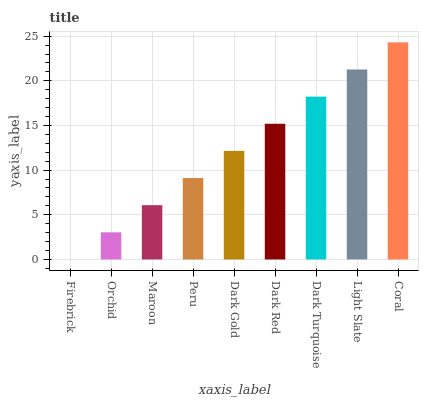Is Firebrick the minimum?
Answer yes or no. Yes. Is Coral the maximum?
Answer yes or no. Yes. Is Orchid the minimum?
Answer yes or no. No. Is Orchid the maximum?
Answer yes or no. No. Is Orchid greater than Firebrick?
Answer yes or no. Yes. Is Firebrick less than Orchid?
Answer yes or no. Yes. Is Firebrick greater than Orchid?
Answer yes or no. No. Is Orchid less than Firebrick?
Answer yes or no. No. Is Dark Gold the high median?
Answer yes or no. Yes. Is Dark Gold the low median?
Answer yes or no. Yes. Is Orchid the high median?
Answer yes or no. No. Is Orchid the low median?
Answer yes or no. No. 